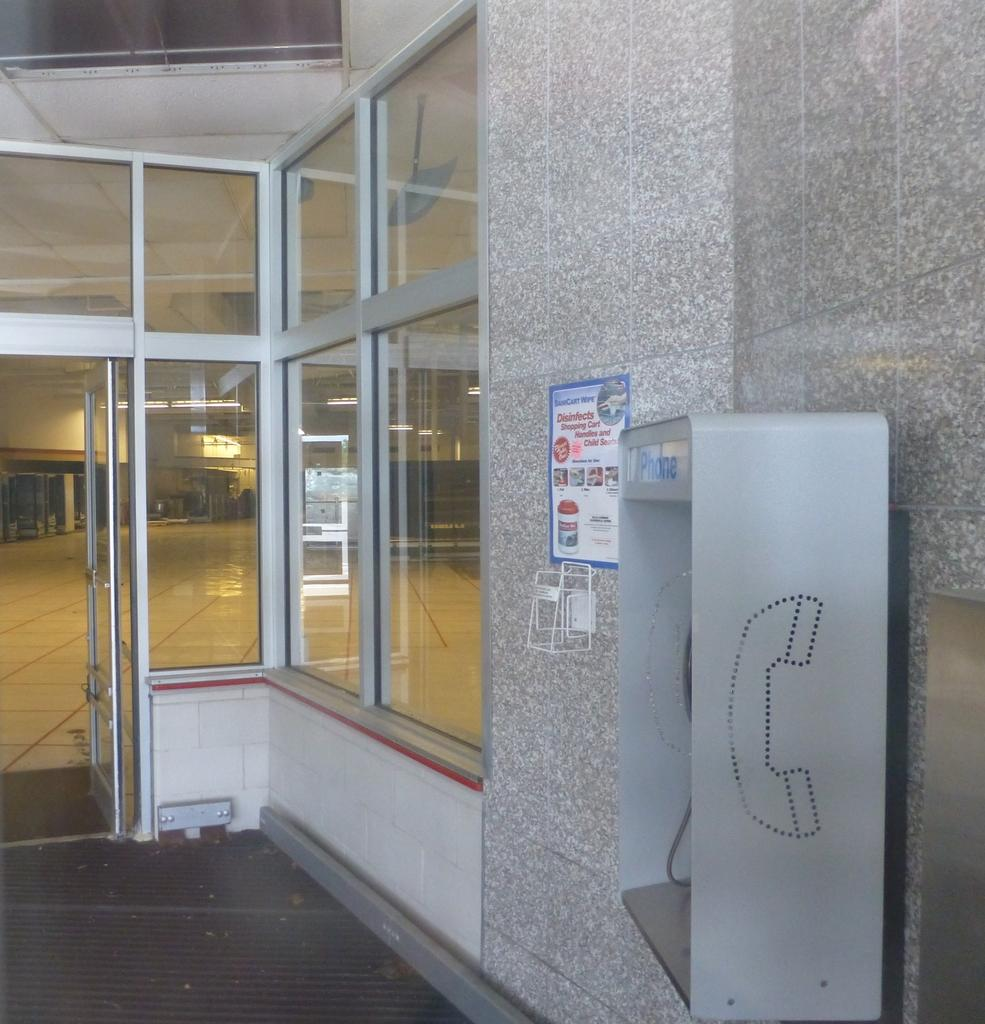What type of structure is visible in the image? There is a building in the image. What feature can be observed on the building? The building has glass windows. What is located in front of the building? There is a telephone booth in front of the building. Can you describe something attached to the wall in the image? There is a pamphlet attached to the wall in the image. What type of sleet can be seen falling from the sky in the image? There is no sleet visible in the image; the sky is not mentioned in the provided facts. 